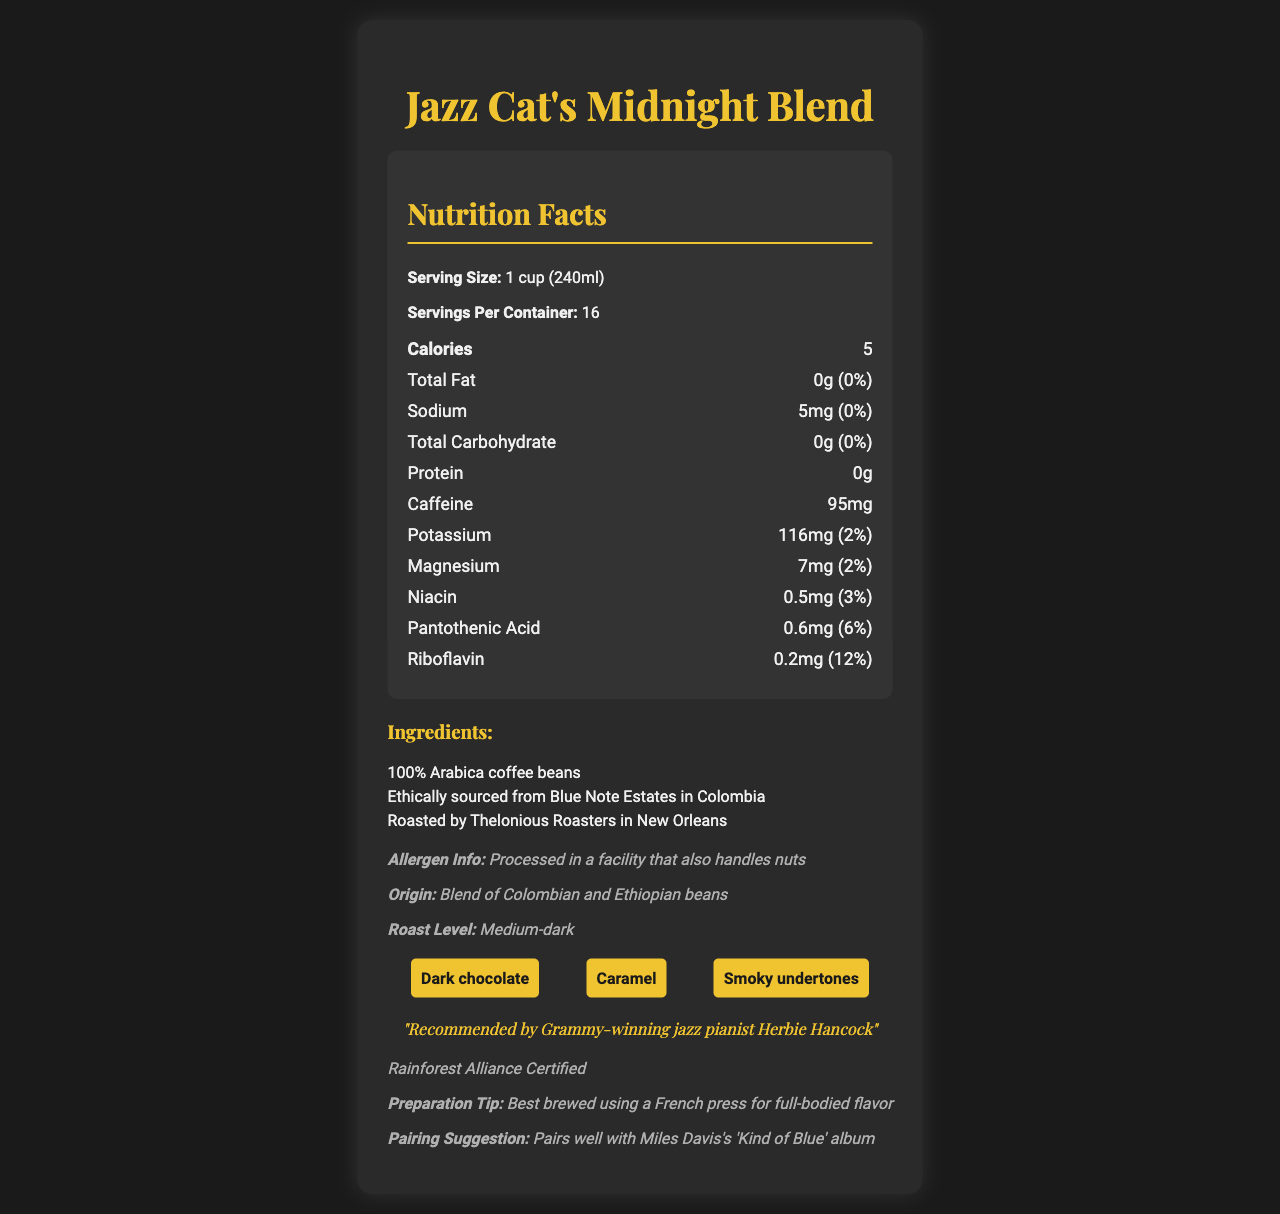What is the serving size for Jazz Cat's Midnight Blend? The serving size is clearly mentioned as "1 cup (240ml)" under the Nutrition Facts section.
Answer: 1 cup (240ml) How many calories are in one serving of Jazz Cat's Midnight Blend? The document states that there are 5 calories per serving.
Answer: 5 What is the caffeine content of Jazz Cat's Midnight Blend per serving? The caffeine content is listed as 95mg under the Nutrition Facts.
Answer: 95mg What is the amount of sodium in one serving, and what percentage of the daily value does it represent? The sodium content is 5mg and it represents 0% of the daily value.
Answer: 5mg, 0% What ingredients are used in Jazz Cat's Midnight Blend? The ingredients are listed under the Ingredients section.
Answer: 100% Arabica coffee beans, Ethically sourced from Blue Note Estates in Colombia, Roasted by Thelonious Roasters in New Orleans How many servings are there per container of Jazz Cat's Midnight Blend? The number of servings per container is listed as 16.
Answer: 16 What is the recommended preparation method for Jazz Cat's Midnight Blend? The preparation tip recommends using a French press for full-bodied flavor.
Answer: Brewed using a French press What are the flavor notes mentioned for Jazz Cat's Midnight Blend? The flavor notes are listed as Dark chocolate, Caramel, and Smoky undertones.
Answer: Dark chocolate, Caramel, Smoky undertones Which Grammy-winning jazz pianist endorses Jazz Cat's Midnight Blend? The musician endorsement section states that it is recommended by Grammy-winning jazz pianist Herbie Hancock.
Answer: Herbie Hancock Is Jazz Cat's Midnight Blend Rainforest Alliance Certified? The document states that it is Rainforest Alliance Certified under the sustainability section.
Answer: Yes Where is Jazz Cat's Midnight Blend sourced from? The origin section lists the sourcing as a blend of Colombian and Ethiopian beans.
Answer: Blend of Colombian and Ethiopian beans What nutrient contributes to the highest percentage of daily value in Jazz Cat's Midnight Blend? Riboflavin contributes 12% of the daily value, which is the highest among the listed nutrients.
Answer: Riboflavin, 12% What pairing suggestion is provided for Jazz Cat's Midnight Blend? The pairing suggestion recommends pairing it with Miles Davis's 'Kind of Blue' album.
Answer: Pairs well with Miles Davis's 'Kind of Blue' album What is the roast level of Jazz Cat's Midnight Blend? The roast level is described as Medium-dark.
Answer: Medium-dark Which of the following nutrients are present in Jazz Cat's Midnight Blend? A. Vitamin C B. Riboflavin C. Iron The document lists Riboflavin as one of the nutrients, but not Vitamin C or Iron.
Answer: B. Riboflavin How much pantothenic acid is in one serving, and what percentage of the daily value does it represent? A. 0.5mg, 5% B. 0.6mg, 6% C. 0.7mg, 7% The document states that there is 0.6mg of pantothenic acid, representing 6% of the daily value.
Answer: B. 0.6mg, 6% Does Jazz Cat's Midnight Blend contain any fats? The total fat content is listed as 0g.
Answer: No Summarize the main idea of the document. This summary encapsulates the key details about the product's nutrition facts, ingredients, recommended preparation, endorsements, and flavor profile.
Answer: Jazz Cat's Midnight Blend is a gourmet coffee blend with low calories and no fats, endorsed by Herbie Hancock. It features a blend of Colombian and Ethiopian beans, roasted to a medium-dark level. It is noted for its dark chocolate, caramel, and smoky flavors, and it is best prepared using a French press. The coffee is Rainforest Alliance Certified and pairs well with Miles Davis's 'Kind of Blue' album. What is the exact sourcing region within Colombia for the coffee beans? The document mentions the beans are sourced from Blue Note Estates in Colombia but does not specify the exact region within Colombia.
Answer: Not enough information 